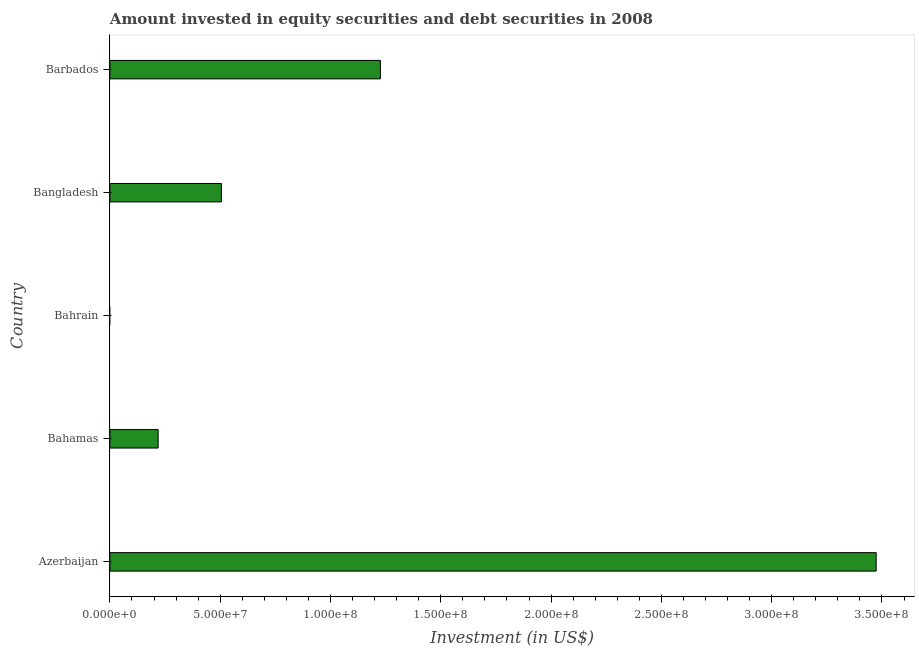Does the graph contain any zero values?
Your answer should be very brief. Yes. What is the title of the graph?
Provide a short and direct response. Amount invested in equity securities and debt securities in 2008. What is the label or title of the X-axis?
Provide a short and direct response. Investment (in US$). What is the label or title of the Y-axis?
Provide a succinct answer. Country. What is the portfolio investment in Bahamas?
Keep it short and to the point. 2.19e+07. Across all countries, what is the maximum portfolio investment?
Keep it short and to the point. 3.47e+08. Across all countries, what is the minimum portfolio investment?
Give a very brief answer. 0. In which country was the portfolio investment maximum?
Keep it short and to the point. Azerbaijan. What is the sum of the portfolio investment?
Give a very brief answer. 5.42e+08. What is the difference between the portfolio investment in Azerbaijan and Bangladesh?
Give a very brief answer. 2.97e+08. What is the average portfolio investment per country?
Keep it short and to the point. 1.08e+08. What is the median portfolio investment?
Your answer should be very brief. 5.06e+07. In how many countries, is the portfolio investment greater than 50000000 US$?
Ensure brevity in your answer.  3. What is the ratio of the portfolio investment in Bahamas to that in Barbados?
Ensure brevity in your answer.  0.18. Is the portfolio investment in Azerbaijan less than that in Bangladesh?
Your answer should be very brief. No. What is the difference between the highest and the second highest portfolio investment?
Give a very brief answer. 2.25e+08. What is the difference between the highest and the lowest portfolio investment?
Keep it short and to the point. 3.47e+08. In how many countries, is the portfolio investment greater than the average portfolio investment taken over all countries?
Provide a succinct answer. 2. How many countries are there in the graph?
Your response must be concise. 5. What is the Investment (in US$) in Azerbaijan?
Provide a short and direct response. 3.47e+08. What is the Investment (in US$) in Bahamas?
Your answer should be very brief. 2.19e+07. What is the Investment (in US$) in Bangladesh?
Provide a short and direct response. 5.06e+07. What is the Investment (in US$) in Barbados?
Your answer should be very brief. 1.23e+08. What is the difference between the Investment (in US$) in Azerbaijan and Bahamas?
Make the answer very short. 3.26e+08. What is the difference between the Investment (in US$) in Azerbaijan and Bangladesh?
Your answer should be very brief. 2.97e+08. What is the difference between the Investment (in US$) in Azerbaijan and Barbados?
Offer a very short reply. 2.25e+08. What is the difference between the Investment (in US$) in Bahamas and Bangladesh?
Give a very brief answer. -2.87e+07. What is the difference between the Investment (in US$) in Bahamas and Barbados?
Provide a short and direct response. -1.01e+08. What is the difference between the Investment (in US$) in Bangladesh and Barbados?
Give a very brief answer. -7.21e+07. What is the ratio of the Investment (in US$) in Azerbaijan to that in Bahamas?
Make the answer very short. 15.89. What is the ratio of the Investment (in US$) in Azerbaijan to that in Bangladesh?
Your answer should be very brief. 6.87. What is the ratio of the Investment (in US$) in Azerbaijan to that in Barbados?
Provide a succinct answer. 2.83. What is the ratio of the Investment (in US$) in Bahamas to that in Bangladesh?
Your answer should be compact. 0.43. What is the ratio of the Investment (in US$) in Bahamas to that in Barbados?
Keep it short and to the point. 0.18. What is the ratio of the Investment (in US$) in Bangladesh to that in Barbados?
Make the answer very short. 0.41. 